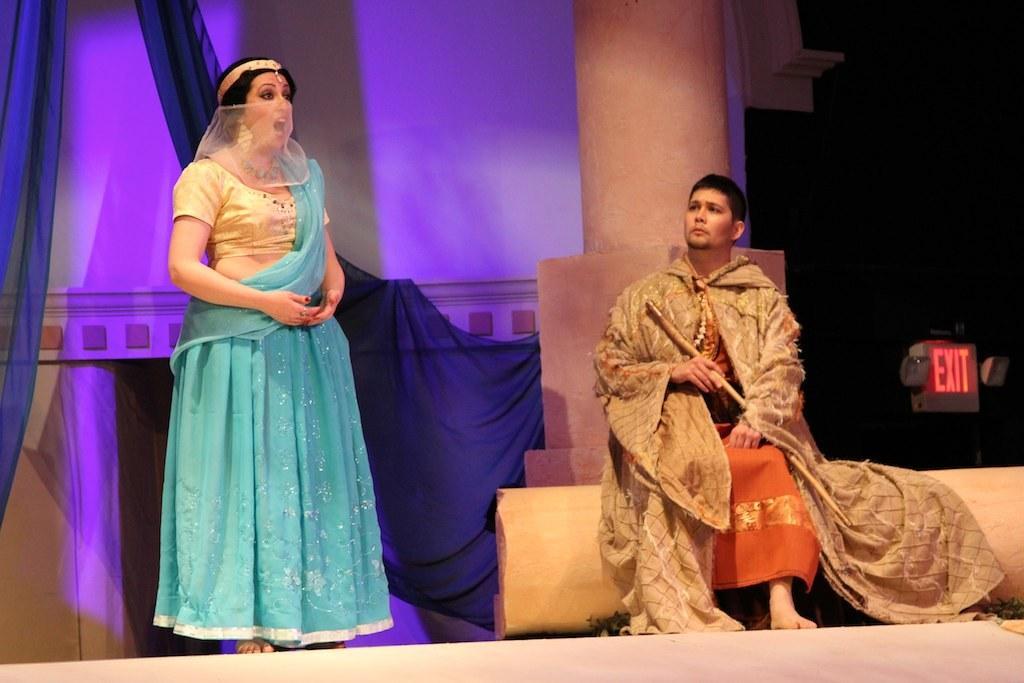Could you give a brief overview of what you see in this image? In the picture a man sitting on an object and holding some object in the hand. On the left side I can see a woman is standing and wearing clothes which is blue in color. On the right side of the image I can see an exit board. In the background I can see curtains, a pillar and some other objects. 